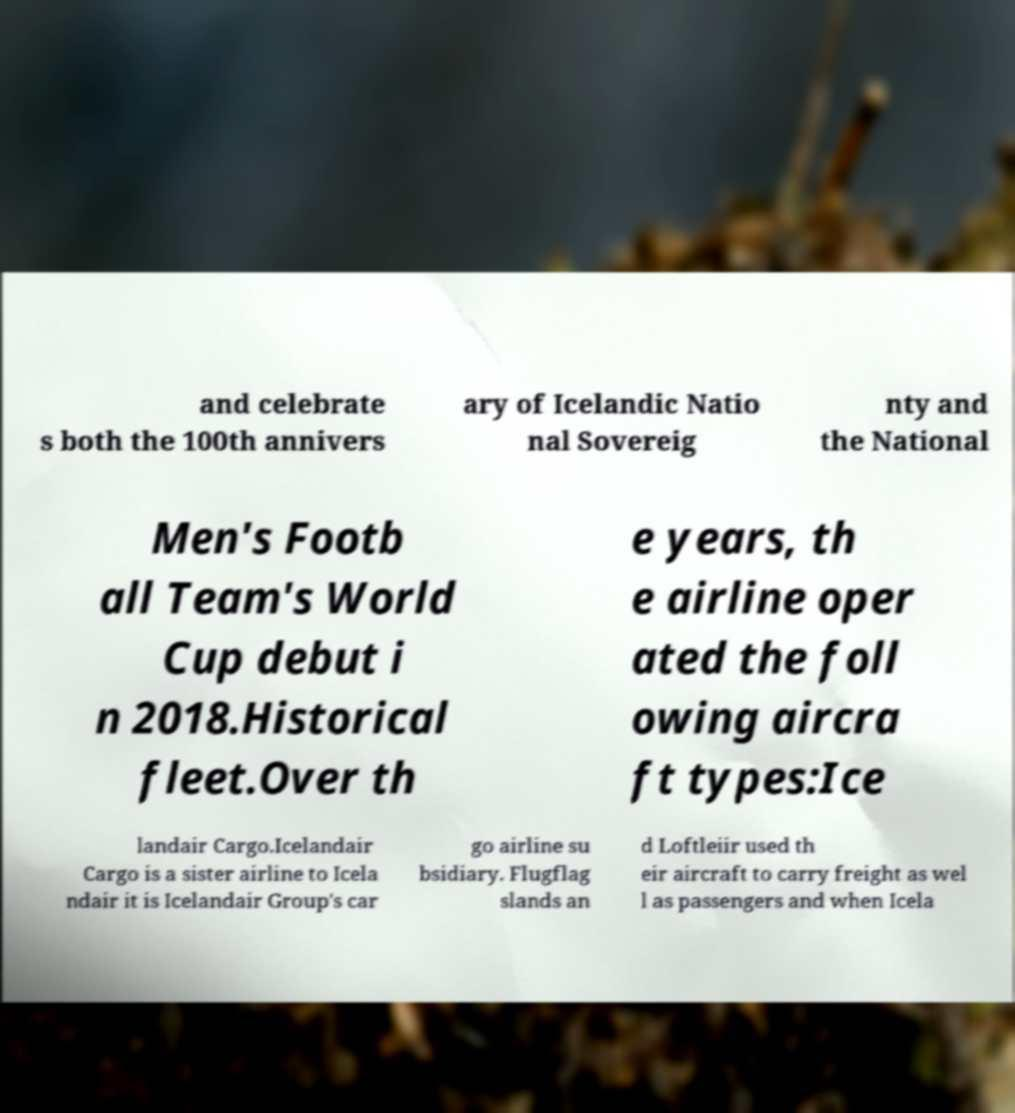Could you assist in decoding the text presented in this image and type it out clearly? and celebrate s both the 100th annivers ary of Icelandic Natio nal Sovereig nty and the National Men's Footb all Team's World Cup debut i n 2018.Historical fleet.Over th e years, th e airline oper ated the foll owing aircra ft types:Ice landair Cargo.Icelandair Cargo is a sister airline to Icela ndair it is Icelandair Group's car go airline su bsidiary. Flugflag slands an d Loftleiir used th eir aircraft to carry freight as wel l as passengers and when Icela 